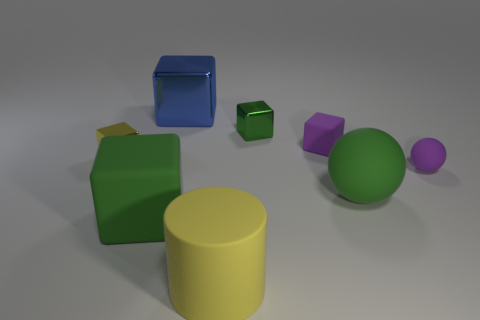Are the purple sphere and the large blue thing made of the same material?
Offer a very short reply. No. How many other things are there of the same material as the big blue cube?
Make the answer very short. 2. How many matte objects are behind the cylinder and on the left side of the small matte sphere?
Provide a short and direct response. 3. The matte cylinder is what color?
Your answer should be very brief. Yellow. What is the material of the large blue thing that is the same shape as the green metallic thing?
Ensure brevity in your answer.  Metal. Is there any other thing that is made of the same material as the blue thing?
Your answer should be compact. Yes. Is the color of the large matte sphere the same as the rubber cylinder?
Provide a succinct answer. No. What shape is the purple rubber thing behind the matte ball that is behind the large rubber sphere?
Your answer should be compact. Cube. What is the shape of the small green thing that is made of the same material as the big blue block?
Your answer should be very brief. Cube. How many other objects are the same shape as the blue metallic thing?
Provide a succinct answer. 4. 